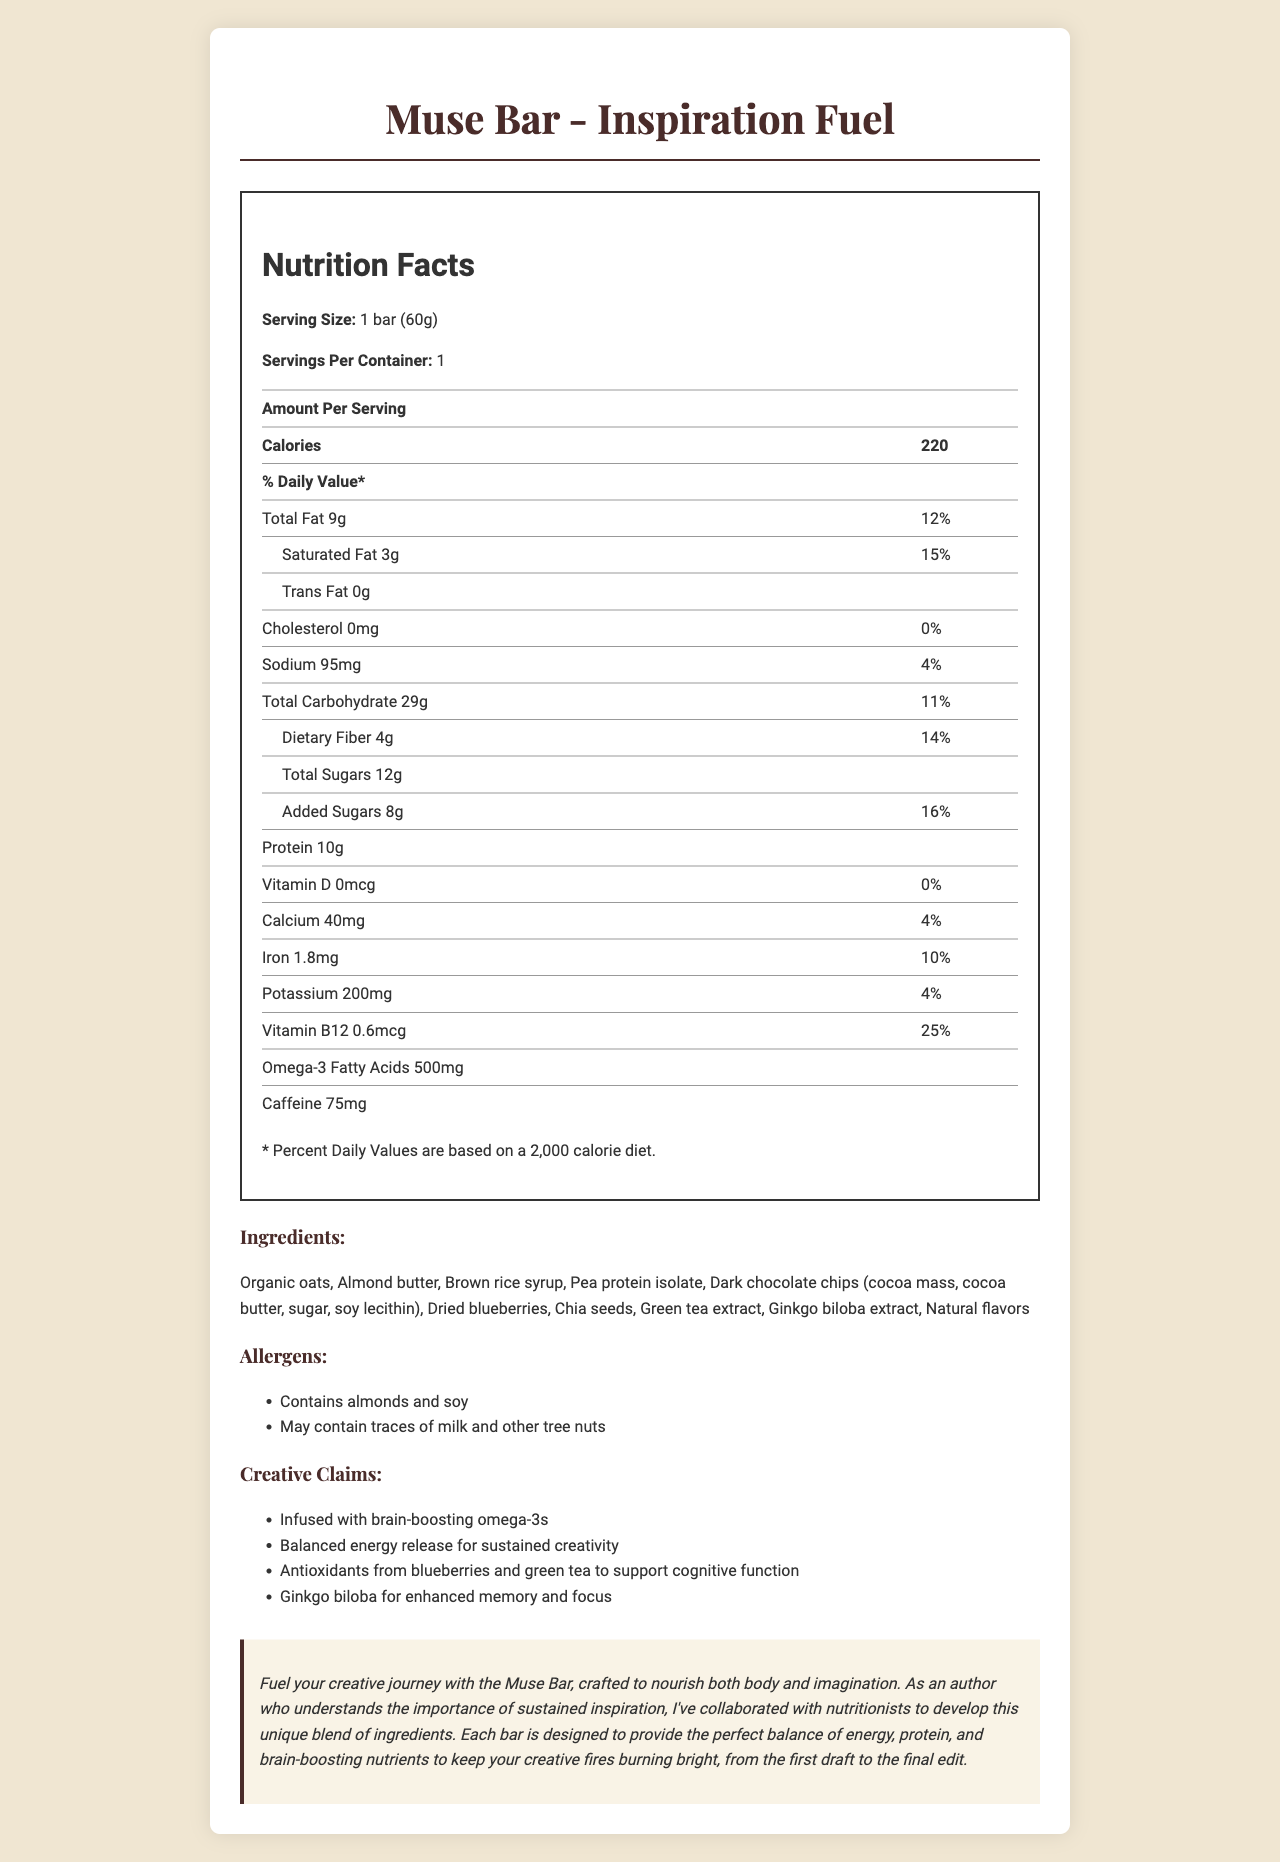what is the serving size of Muse Bar - Inspiration Fuel? The nutrition facts label specifies that the serving size is 1 bar (60g).
Answer: 1 bar (60g) how many calories are in one serving of Muse Bar? The document states that each serving contains 220 calories.
Answer: 220 what is the amount of vitamin B12 present in Muse Bar? According to the nutrition facts table, the amount of vitamin B12 per serving is 0.6mcg.
Answer: 0.6mcg which ingredient contains potential allergens? The document lists almonds and soy as allergens, and almond butter is one of the ingredients.
Answer: Almond butter what are the brain-boosting claims made for the Muse Bar? These claims are mentioned under the "Creative Claims" section.
Answer: Infused with brain-boosting omega-3s, antioxidants from blueberries and green tea to support cognitive function, and ginkgo biloba for enhanced memory and focus how much dietary fiber is in each bar? A. 2g B. 4g C. 5g D. 6g The nutrition facts state that each serving contains 4g of dietary fiber.
Answer: B. 4g which nutrient has the highest daily value percentage in Muse Bar? A. Dietary Fiber B. Added Sugars C. Vitamin B12 D. Protein Vitamin B12 has the highest daily value percentage at 25%.
Answer: C. Vitamin B12 is there any cholesterol in the Muse Bar? The document indicates that the amount of cholesterol is 0mg, which corresponds to 0% of the daily value.
Answer: No describe the overall theme and purpose of the Muse Bar product page. This summary covers the nutritional details, ingredient information, allergen notes, and the creative claims made for the product.
Answer: The Muse Bar product page provides detailed nutritional information and emphasizes that the bar is designed to fuel creativity and sustain inspiration. It highlights its unique blend of ingredients aimed at supporting cognitive function and balanced energy release. what is the omega-3 fatty acids content in Muse Bar? The nutrition facts table lists 500mg of omega-3 fatty acids per serving.
Answer: 500mg what percentage of the daily value does added sugars cover? The document indicates that the added sugars account for 16% of the daily value.
Answer: 16% what is the primary source of protein in the bar? Among the ingredients listed, pea protein isolate is identified as the primary source of protein.
Answer: Pea protein isolate how many servings are there per container? The document specifies that there is 1 serving per container.
Answer: 1 which flavoring or extract in Muse Bar is intended to support cognitive function? A. Almond Butter B. Green Tea Extract C. Dried Blueberries D. Brown Rice Syrup The document mentions green tea extract as one of the sources of antioxidants to support cognitive function.
Answer: B. Green Tea Extract does the Muse Bar contain caffeine? The nutrition facts table lists caffeine content as 75mg.
Answer: Yes how much potassium is in one Muse Bar? The amount of potassium per serving is specified as 200mg in the document.
Answer: 200mg what is the recommended daily calorie intake for the percentages given in the nutrition facts? The document states that the percent daily values are based on a 2,000 calorie diet.
Answer: 2,000 calories is there enough information in the document to determine the manufacturing date of the Muse Bar? The document does not provide any details regarding the manufacturing date.
Answer: Not enough information how much iron is in one serving of the Muse Bar? The nutrition facts state that each serving contains 1.8mg of iron.
Answer: 1.8mg what are the ingredients that may contain traces of milk? The allergen information mentions that the product may contain traces of milk and other tree nuts.
Answer: Almonds and other tree nuts 